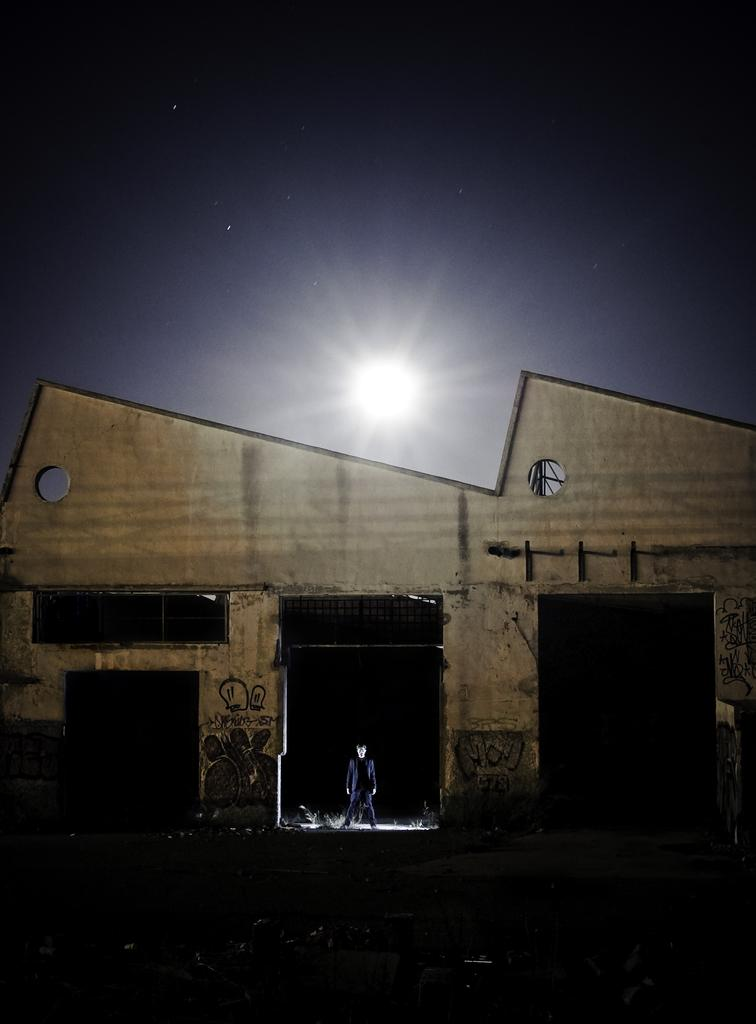What type of structure is visible in the image? There is a house in the image. What are the main features of the house? The house has walls and grills. Are there any decorative elements in the image? Yes, there are paintings in the image. Can you describe the person in the image? A person is standing in the image. How would you describe the background of the image? The background of the image has a dark view. What type of fiction is the person reading in the image? There is no indication in the image that the person is reading any fiction. Can you tell me how many screws are visible in the image? There are no screws present in the image. 